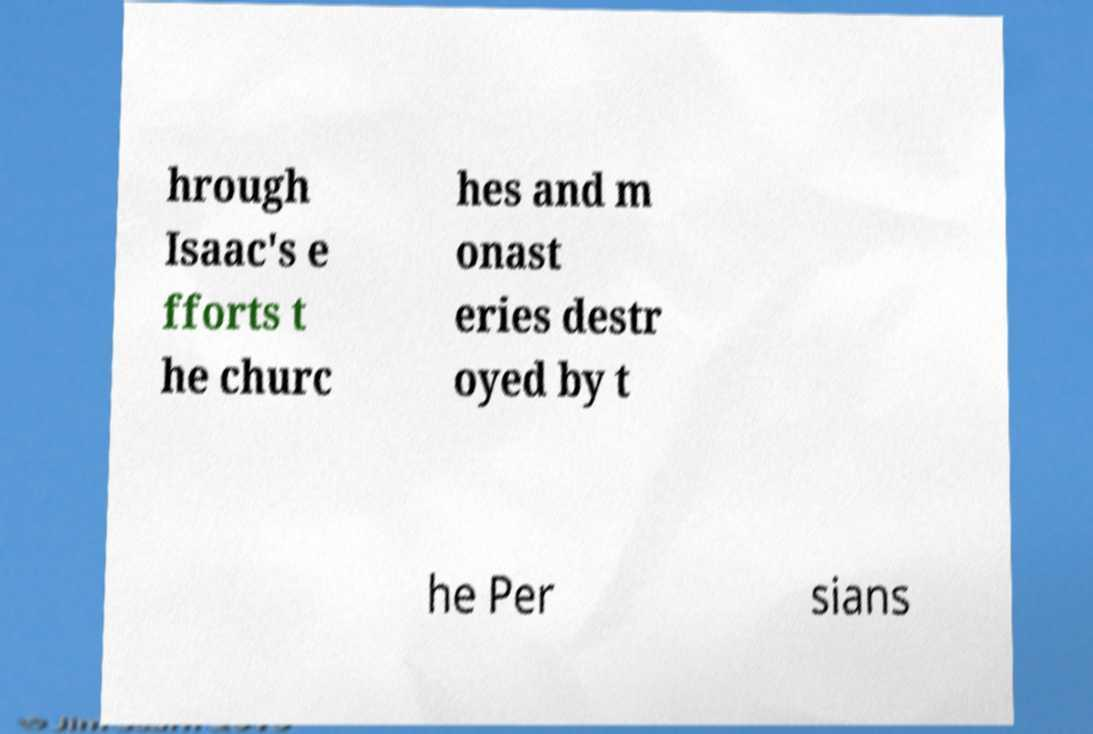Could you extract and type out the text from this image? hrough Isaac's e fforts t he churc hes and m onast eries destr oyed by t he Per sians 